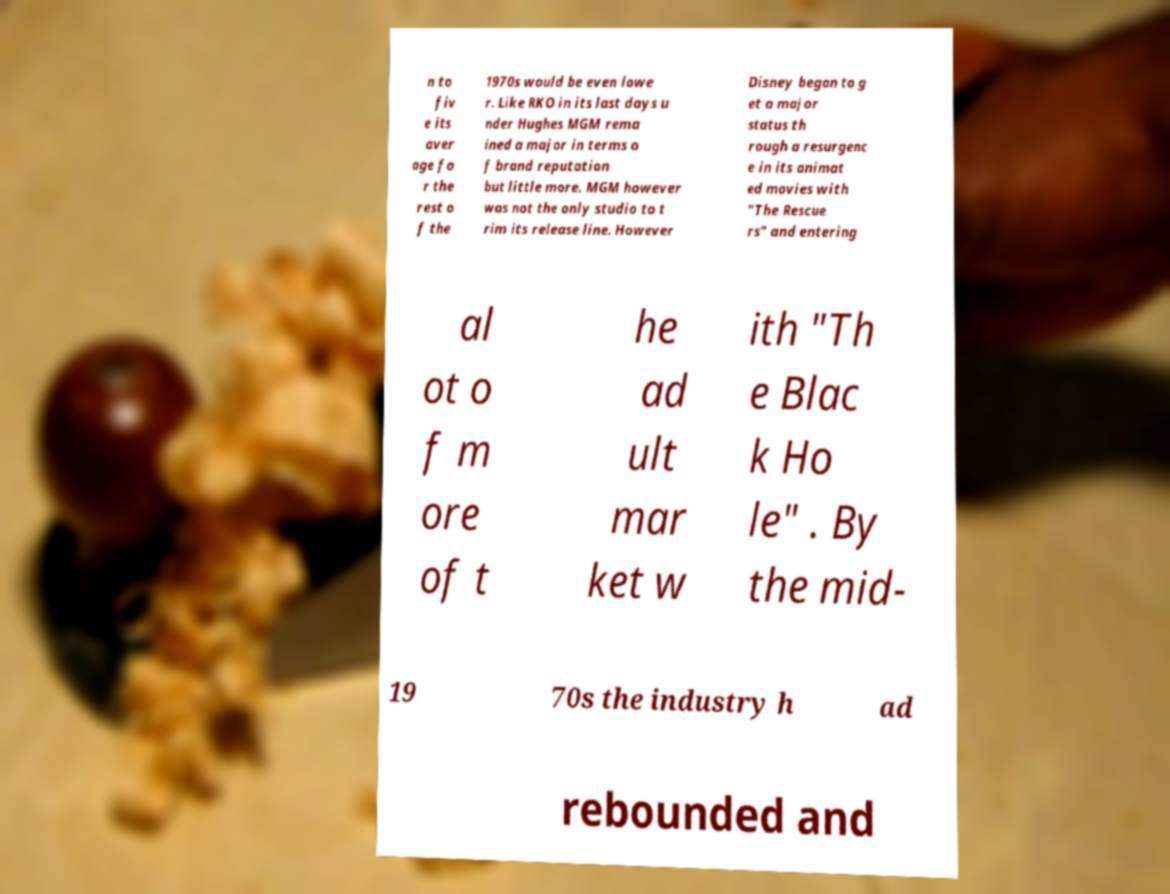Can you read and provide the text displayed in the image?This photo seems to have some interesting text. Can you extract and type it out for me? n to fiv e its aver age fo r the rest o f the 1970s would be even lowe r. Like RKO in its last days u nder Hughes MGM rema ined a major in terms o f brand reputation but little more. MGM however was not the only studio to t rim its release line. However Disney began to g et a major status th rough a resurgenc e in its animat ed movies with "The Rescue rs" and entering al ot o f m ore of t he ad ult mar ket w ith "Th e Blac k Ho le" . By the mid- 19 70s the industry h ad rebounded and 